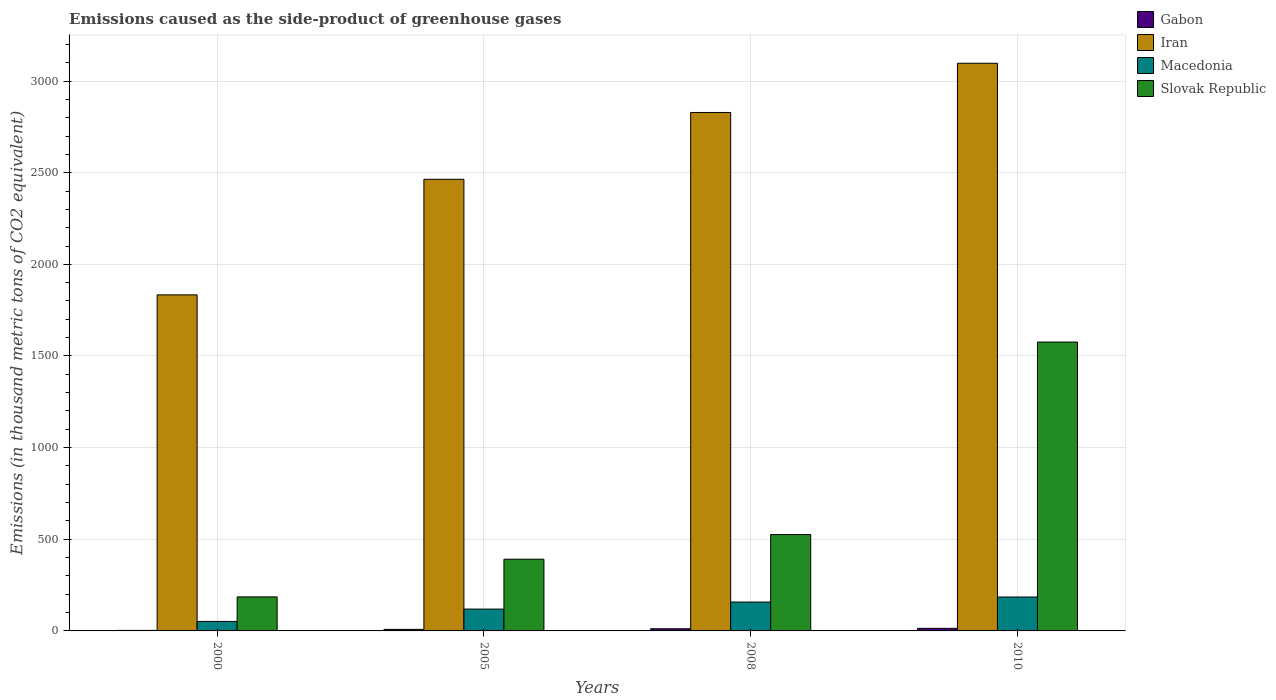What is the label of the 3rd group of bars from the left?
Your response must be concise. 2008. What is the emissions caused as the side-product of greenhouse gases in Iran in 2005?
Keep it short and to the point. 2464. Across all years, what is the maximum emissions caused as the side-product of greenhouse gases in Macedonia?
Your response must be concise. 185. Across all years, what is the minimum emissions caused as the side-product of greenhouse gases in Slovak Republic?
Your response must be concise. 185.6. In which year was the emissions caused as the side-product of greenhouse gases in Macedonia maximum?
Ensure brevity in your answer.  2010. What is the total emissions caused as the side-product of greenhouse gases in Macedonia in the graph?
Your answer should be very brief. 513.5. What is the difference between the emissions caused as the side-product of greenhouse gases in Slovak Republic in 2000 and that in 2005?
Keep it short and to the point. -205.7. What is the difference between the emissions caused as the side-product of greenhouse gases in Macedonia in 2000 and the emissions caused as the side-product of greenhouse gases in Iran in 2010?
Provide a succinct answer. -3045.2. What is the average emissions caused as the side-product of greenhouse gases in Slovak Republic per year?
Provide a succinct answer. 669.67. In the year 2010, what is the difference between the emissions caused as the side-product of greenhouse gases in Iran and emissions caused as the side-product of greenhouse gases in Slovak Republic?
Your answer should be very brief. 1521. In how many years, is the emissions caused as the side-product of greenhouse gases in Gabon greater than 2000 thousand metric tons?
Your response must be concise. 0. What is the ratio of the emissions caused as the side-product of greenhouse gases in Iran in 2000 to that in 2010?
Ensure brevity in your answer.  0.59. What is the difference between the highest and the second highest emissions caused as the side-product of greenhouse gases in Macedonia?
Give a very brief answer. 27.4. What is the difference between the highest and the lowest emissions caused as the side-product of greenhouse gases in Macedonia?
Provide a short and direct response. 133.2. Is the sum of the emissions caused as the side-product of greenhouse gases in Gabon in 2005 and 2008 greater than the maximum emissions caused as the side-product of greenhouse gases in Macedonia across all years?
Ensure brevity in your answer.  No. Is it the case that in every year, the sum of the emissions caused as the side-product of greenhouse gases in Gabon and emissions caused as the side-product of greenhouse gases in Slovak Republic is greater than the sum of emissions caused as the side-product of greenhouse gases in Iran and emissions caused as the side-product of greenhouse gases in Macedonia?
Give a very brief answer. No. What does the 1st bar from the left in 2000 represents?
Give a very brief answer. Gabon. What does the 2nd bar from the right in 2008 represents?
Make the answer very short. Macedonia. Is it the case that in every year, the sum of the emissions caused as the side-product of greenhouse gases in Gabon and emissions caused as the side-product of greenhouse gases in Iran is greater than the emissions caused as the side-product of greenhouse gases in Macedonia?
Offer a terse response. Yes. What is the difference between two consecutive major ticks on the Y-axis?
Give a very brief answer. 500. Are the values on the major ticks of Y-axis written in scientific E-notation?
Ensure brevity in your answer.  No. Does the graph contain grids?
Provide a short and direct response. Yes. Where does the legend appear in the graph?
Provide a short and direct response. Top right. How many legend labels are there?
Give a very brief answer. 4. How are the legend labels stacked?
Your answer should be compact. Vertical. What is the title of the graph?
Offer a very short reply. Emissions caused as the side-product of greenhouse gases. Does "Gambia, The" appear as one of the legend labels in the graph?
Your answer should be very brief. No. What is the label or title of the Y-axis?
Provide a succinct answer. Emissions (in thousand metric tons of CO2 equivalent). What is the Emissions (in thousand metric tons of CO2 equivalent) of Gabon in 2000?
Your answer should be very brief. 2.9. What is the Emissions (in thousand metric tons of CO2 equivalent) in Iran in 2000?
Make the answer very short. 1833.4. What is the Emissions (in thousand metric tons of CO2 equivalent) of Macedonia in 2000?
Provide a short and direct response. 51.8. What is the Emissions (in thousand metric tons of CO2 equivalent) of Slovak Republic in 2000?
Your answer should be compact. 185.6. What is the Emissions (in thousand metric tons of CO2 equivalent) of Gabon in 2005?
Offer a very short reply. 8.4. What is the Emissions (in thousand metric tons of CO2 equivalent) of Iran in 2005?
Offer a terse response. 2464. What is the Emissions (in thousand metric tons of CO2 equivalent) in Macedonia in 2005?
Provide a short and direct response. 119.1. What is the Emissions (in thousand metric tons of CO2 equivalent) of Slovak Republic in 2005?
Offer a terse response. 391.3. What is the Emissions (in thousand metric tons of CO2 equivalent) of Iran in 2008?
Provide a short and direct response. 2828.5. What is the Emissions (in thousand metric tons of CO2 equivalent) in Macedonia in 2008?
Your answer should be very brief. 157.6. What is the Emissions (in thousand metric tons of CO2 equivalent) of Slovak Republic in 2008?
Your answer should be compact. 525.8. What is the Emissions (in thousand metric tons of CO2 equivalent) in Iran in 2010?
Provide a succinct answer. 3097. What is the Emissions (in thousand metric tons of CO2 equivalent) in Macedonia in 2010?
Your response must be concise. 185. What is the Emissions (in thousand metric tons of CO2 equivalent) of Slovak Republic in 2010?
Offer a terse response. 1576. Across all years, what is the maximum Emissions (in thousand metric tons of CO2 equivalent) in Iran?
Your answer should be very brief. 3097. Across all years, what is the maximum Emissions (in thousand metric tons of CO2 equivalent) in Macedonia?
Your answer should be very brief. 185. Across all years, what is the maximum Emissions (in thousand metric tons of CO2 equivalent) of Slovak Republic?
Your answer should be compact. 1576. Across all years, what is the minimum Emissions (in thousand metric tons of CO2 equivalent) of Gabon?
Your answer should be very brief. 2.9. Across all years, what is the minimum Emissions (in thousand metric tons of CO2 equivalent) of Iran?
Your answer should be very brief. 1833.4. Across all years, what is the minimum Emissions (in thousand metric tons of CO2 equivalent) in Macedonia?
Offer a terse response. 51.8. Across all years, what is the minimum Emissions (in thousand metric tons of CO2 equivalent) of Slovak Republic?
Your answer should be very brief. 185.6. What is the total Emissions (in thousand metric tons of CO2 equivalent) of Gabon in the graph?
Your response must be concise. 37.1. What is the total Emissions (in thousand metric tons of CO2 equivalent) in Iran in the graph?
Offer a very short reply. 1.02e+04. What is the total Emissions (in thousand metric tons of CO2 equivalent) of Macedonia in the graph?
Your answer should be very brief. 513.5. What is the total Emissions (in thousand metric tons of CO2 equivalent) in Slovak Republic in the graph?
Offer a very short reply. 2678.7. What is the difference between the Emissions (in thousand metric tons of CO2 equivalent) in Gabon in 2000 and that in 2005?
Offer a terse response. -5.5. What is the difference between the Emissions (in thousand metric tons of CO2 equivalent) in Iran in 2000 and that in 2005?
Make the answer very short. -630.6. What is the difference between the Emissions (in thousand metric tons of CO2 equivalent) in Macedonia in 2000 and that in 2005?
Offer a terse response. -67.3. What is the difference between the Emissions (in thousand metric tons of CO2 equivalent) in Slovak Republic in 2000 and that in 2005?
Your response must be concise. -205.7. What is the difference between the Emissions (in thousand metric tons of CO2 equivalent) of Iran in 2000 and that in 2008?
Provide a short and direct response. -995.1. What is the difference between the Emissions (in thousand metric tons of CO2 equivalent) of Macedonia in 2000 and that in 2008?
Provide a succinct answer. -105.8. What is the difference between the Emissions (in thousand metric tons of CO2 equivalent) in Slovak Republic in 2000 and that in 2008?
Offer a very short reply. -340.2. What is the difference between the Emissions (in thousand metric tons of CO2 equivalent) of Iran in 2000 and that in 2010?
Provide a short and direct response. -1263.6. What is the difference between the Emissions (in thousand metric tons of CO2 equivalent) of Macedonia in 2000 and that in 2010?
Offer a very short reply. -133.2. What is the difference between the Emissions (in thousand metric tons of CO2 equivalent) in Slovak Republic in 2000 and that in 2010?
Your answer should be compact. -1390.4. What is the difference between the Emissions (in thousand metric tons of CO2 equivalent) in Gabon in 2005 and that in 2008?
Make the answer very short. -3.4. What is the difference between the Emissions (in thousand metric tons of CO2 equivalent) in Iran in 2005 and that in 2008?
Provide a succinct answer. -364.5. What is the difference between the Emissions (in thousand metric tons of CO2 equivalent) in Macedonia in 2005 and that in 2008?
Ensure brevity in your answer.  -38.5. What is the difference between the Emissions (in thousand metric tons of CO2 equivalent) of Slovak Republic in 2005 and that in 2008?
Your answer should be very brief. -134.5. What is the difference between the Emissions (in thousand metric tons of CO2 equivalent) in Iran in 2005 and that in 2010?
Offer a very short reply. -633. What is the difference between the Emissions (in thousand metric tons of CO2 equivalent) of Macedonia in 2005 and that in 2010?
Provide a short and direct response. -65.9. What is the difference between the Emissions (in thousand metric tons of CO2 equivalent) in Slovak Republic in 2005 and that in 2010?
Give a very brief answer. -1184.7. What is the difference between the Emissions (in thousand metric tons of CO2 equivalent) in Iran in 2008 and that in 2010?
Provide a succinct answer. -268.5. What is the difference between the Emissions (in thousand metric tons of CO2 equivalent) in Macedonia in 2008 and that in 2010?
Your answer should be compact. -27.4. What is the difference between the Emissions (in thousand metric tons of CO2 equivalent) of Slovak Republic in 2008 and that in 2010?
Keep it short and to the point. -1050.2. What is the difference between the Emissions (in thousand metric tons of CO2 equivalent) in Gabon in 2000 and the Emissions (in thousand metric tons of CO2 equivalent) in Iran in 2005?
Keep it short and to the point. -2461.1. What is the difference between the Emissions (in thousand metric tons of CO2 equivalent) of Gabon in 2000 and the Emissions (in thousand metric tons of CO2 equivalent) of Macedonia in 2005?
Ensure brevity in your answer.  -116.2. What is the difference between the Emissions (in thousand metric tons of CO2 equivalent) of Gabon in 2000 and the Emissions (in thousand metric tons of CO2 equivalent) of Slovak Republic in 2005?
Ensure brevity in your answer.  -388.4. What is the difference between the Emissions (in thousand metric tons of CO2 equivalent) in Iran in 2000 and the Emissions (in thousand metric tons of CO2 equivalent) in Macedonia in 2005?
Keep it short and to the point. 1714.3. What is the difference between the Emissions (in thousand metric tons of CO2 equivalent) in Iran in 2000 and the Emissions (in thousand metric tons of CO2 equivalent) in Slovak Republic in 2005?
Your answer should be compact. 1442.1. What is the difference between the Emissions (in thousand metric tons of CO2 equivalent) in Macedonia in 2000 and the Emissions (in thousand metric tons of CO2 equivalent) in Slovak Republic in 2005?
Ensure brevity in your answer.  -339.5. What is the difference between the Emissions (in thousand metric tons of CO2 equivalent) in Gabon in 2000 and the Emissions (in thousand metric tons of CO2 equivalent) in Iran in 2008?
Offer a terse response. -2825.6. What is the difference between the Emissions (in thousand metric tons of CO2 equivalent) in Gabon in 2000 and the Emissions (in thousand metric tons of CO2 equivalent) in Macedonia in 2008?
Provide a short and direct response. -154.7. What is the difference between the Emissions (in thousand metric tons of CO2 equivalent) of Gabon in 2000 and the Emissions (in thousand metric tons of CO2 equivalent) of Slovak Republic in 2008?
Keep it short and to the point. -522.9. What is the difference between the Emissions (in thousand metric tons of CO2 equivalent) in Iran in 2000 and the Emissions (in thousand metric tons of CO2 equivalent) in Macedonia in 2008?
Offer a very short reply. 1675.8. What is the difference between the Emissions (in thousand metric tons of CO2 equivalent) in Iran in 2000 and the Emissions (in thousand metric tons of CO2 equivalent) in Slovak Republic in 2008?
Make the answer very short. 1307.6. What is the difference between the Emissions (in thousand metric tons of CO2 equivalent) in Macedonia in 2000 and the Emissions (in thousand metric tons of CO2 equivalent) in Slovak Republic in 2008?
Offer a terse response. -474. What is the difference between the Emissions (in thousand metric tons of CO2 equivalent) in Gabon in 2000 and the Emissions (in thousand metric tons of CO2 equivalent) in Iran in 2010?
Your response must be concise. -3094.1. What is the difference between the Emissions (in thousand metric tons of CO2 equivalent) of Gabon in 2000 and the Emissions (in thousand metric tons of CO2 equivalent) of Macedonia in 2010?
Your answer should be very brief. -182.1. What is the difference between the Emissions (in thousand metric tons of CO2 equivalent) of Gabon in 2000 and the Emissions (in thousand metric tons of CO2 equivalent) of Slovak Republic in 2010?
Offer a very short reply. -1573.1. What is the difference between the Emissions (in thousand metric tons of CO2 equivalent) in Iran in 2000 and the Emissions (in thousand metric tons of CO2 equivalent) in Macedonia in 2010?
Keep it short and to the point. 1648.4. What is the difference between the Emissions (in thousand metric tons of CO2 equivalent) in Iran in 2000 and the Emissions (in thousand metric tons of CO2 equivalent) in Slovak Republic in 2010?
Your answer should be compact. 257.4. What is the difference between the Emissions (in thousand metric tons of CO2 equivalent) of Macedonia in 2000 and the Emissions (in thousand metric tons of CO2 equivalent) of Slovak Republic in 2010?
Your answer should be very brief. -1524.2. What is the difference between the Emissions (in thousand metric tons of CO2 equivalent) of Gabon in 2005 and the Emissions (in thousand metric tons of CO2 equivalent) of Iran in 2008?
Provide a succinct answer. -2820.1. What is the difference between the Emissions (in thousand metric tons of CO2 equivalent) of Gabon in 2005 and the Emissions (in thousand metric tons of CO2 equivalent) of Macedonia in 2008?
Make the answer very short. -149.2. What is the difference between the Emissions (in thousand metric tons of CO2 equivalent) of Gabon in 2005 and the Emissions (in thousand metric tons of CO2 equivalent) of Slovak Republic in 2008?
Your answer should be very brief. -517.4. What is the difference between the Emissions (in thousand metric tons of CO2 equivalent) in Iran in 2005 and the Emissions (in thousand metric tons of CO2 equivalent) in Macedonia in 2008?
Offer a terse response. 2306.4. What is the difference between the Emissions (in thousand metric tons of CO2 equivalent) of Iran in 2005 and the Emissions (in thousand metric tons of CO2 equivalent) of Slovak Republic in 2008?
Offer a very short reply. 1938.2. What is the difference between the Emissions (in thousand metric tons of CO2 equivalent) in Macedonia in 2005 and the Emissions (in thousand metric tons of CO2 equivalent) in Slovak Republic in 2008?
Your answer should be very brief. -406.7. What is the difference between the Emissions (in thousand metric tons of CO2 equivalent) in Gabon in 2005 and the Emissions (in thousand metric tons of CO2 equivalent) in Iran in 2010?
Make the answer very short. -3088.6. What is the difference between the Emissions (in thousand metric tons of CO2 equivalent) of Gabon in 2005 and the Emissions (in thousand metric tons of CO2 equivalent) of Macedonia in 2010?
Your answer should be compact. -176.6. What is the difference between the Emissions (in thousand metric tons of CO2 equivalent) in Gabon in 2005 and the Emissions (in thousand metric tons of CO2 equivalent) in Slovak Republic in 2010?
Give a very brief answer. -1567.6. What is the difference between the Emissions (in thousand metric tons of CO2 equivalent) of Iran in 2005 and the Emissions (in thousand metric tons of CO2 equivalent) of Macedonia in 2010?
Give a very brief answer. 2279. What is the difference between the Emissions (in thousand metric tons of CO2 equivalent) in Iran in 2005 and the Emissions (in thousand metric tons of CO2 equivalent) in Slovak Republic in 2010?
Your answer should be compact. 888. What is the difference between the Emissions (in thousand metric tons of CO2 equivalent) of Macedonia in 2005 and the Emissions (in thousand metric tons of CO2 equivalent) of Slovak Republic in 2010?
Your answer should be very brief. -1456.9. What is the difference between the Emissions (in thousand metric tons of CO2 equivalent) of Gabon in 2008 and the Emissions (in thousand metric tons of CO2 equivalent) of Iran in 2010?
Your answer should be compact. -3085.2. What is the difference between the Emissions (in thousand metric tons of CO2 equivalent) in Gabon in 2008 and the Emissions (in thousand metric tons of CO2 equivalent) in Macedonia in 2010?
Ensure brevity in your answer.  -173.2. What is the difference between the Emissions (in thousand metric tons of CO2 equivalent) of Gabon in 2008 and the Emissions (in thousand metric tons of CO2 equivalent) of Slovak Republic in 2010?
Your answer should be very brief. -1564.2. What is the difference between the Emissions (in thousand metric tons of CO2 equivalent) of Iran in 2008 and the Emissions (in thousand metric tons of CO2 equivalent) of Macedonia in 2010?
Make the answer very short. 2643.5. What is the difference between the Emissions (in thousand metric tons of CO2 equivalent) of Iran in 2008 and the Emissions (in thousand metric tons of CO2 equivalent) of Slovak Republic in 2010?
Provide a short and direct response. 1252.5. What is the difference between the Emissions (in thousand metric tons of CO2 equivalent) in Macedonia in 2008 and the Emissions (in thousand metric tons of CO2 equivalent) in Slovak Republic in 2010?
Keep it short and to the point. -1418.4. What is the average Emissions (in thousand metric tons of CO2 equivalent) of Gabon per year?
Your answer should be compact. 9.28. What is the average Emissions (in thousand metric tons of CO2 equivalent) in Iran per year?
Offer a terse response. 2555.72. What is the average Emissions (in thousand metric tons of CO2 equivalent) of Macedonia per year?
Your answer should be compact. 128.38. What is the average Emissions (in thousand metric tons of CO2 equivalent) of Slovak Republic per year?
Your answer should be very brief. 669.67. In the year 2000, what is the difference between the Emissions (in thousand metric tons of CO2 equivalent) in Gabon and Emissions (in thousand metric tons of CO2 equivalent) in Iran?
Offer a very short reply. -1830.5. In the year 2000, what is the difference between the Emissions (in thousand metric tons of CO2 equivalent) of Gabon and Emissions (in thousand metric tons of CO2 equivalent) of Macedonia?
Your answer should be compact. -48.9. In the year 2000, what is the difference between the Emissions (in thousand metric tons of CO2 equivalent) in Gabon and Emissions (in thousand metric tons of CO2 equivalent) in Slovak Republic?
Provide a short and direct response. -182.7. In the year 2000, what is the difference between the Emissions (in thousand metric tons of CO2 equivalent) of Iran and Emissions (in thousand metric tons of CO2 equivalent) of Macedonia?
Provide a short and direct response. 1781.6. In the year 2000, what is the difference between the Emissions (in thousand metric tons of CO2 equivalent) in Iran and Emissions (in thousand metric tons of CO2 equivalent) in Slovak Republic?
Ensure brevity in your answer.  1647.8. In the year 2000, what is the difference between the Emissions (in thousand metric tons of CO2 equivalent) of Macedonia and Emissions (in thousand metric tons of CO2 equivalent) of Slovak Republic?
Provide a short and direct response. -133.8. In the year 2005, what is the difference between the Emissions (in thousand metric tons of CO2 equivalent) of Gabon and Emissions (in thousand metric tons of CO2 equivalent) of Iran?
Your response must be concise. -2455.6. In the year 2005, what is the difference between the Emissions (in thousand metric tons of CO2 equivalent) in Gabon and Emissions (in thousand metric tons of CO2 equivalent) in Macedonia?
Keep it short and to the point. -110.7. In the year 2005, what is the difference between the Emissions (in thousand metric tons of CO2 equivalent) in Gabon and Emissions (in thousand metric tons of CO2 equivalent) in Slovak Republic?
Your answer should be very brief. -382.9. In the year 2005, what is the difference between the Emissions (in thousand metric tons of CO2 equivalent) in Iran and Emissions (in thousand metric tons of CO2 equivalent) in Macedonia?
Offer a terse response. 2344.9. In the year 2005, what is the difference between the Emissions (in thousand metric tons of CO2 equivalent) of Iran and Emissions (in thousand metric tons of CO2 equivalent) of Slovak Republic?
Keep it short and to the point. 2072.7. In the year 2005, what is the difference between the Emissions (in thousand metric tons of CO2 equivalent) in Macedonia and Emissions (in thousand metric tons of CO2 equivalent) in Slovak Republic?
Offer a terse response. -272.2. In the year 2008, what is the difference between the Emissions (in thousand metric tons of CO2 equivalent) of Gabon and Emissions (in thousand metric tons of CO2 equivalent) of Iran?
Provide a succinct answer. -2816.7. In the year 2008, what is the difference between the Emissions (in thousand metric tons of CO2 equivalent) in Gabon and Emissions (in thousand metric tons of CO2 equivalent) in Macedonia?
Ensure brevity in your answer.  -145.8. In the year 2008, what is the difference between the Emissions (in thousand metric tons of CO2 equivalent) in Gabon and Emissions (in thousand metric tons of CO2 equivalent) in Slovak Republic?
Give a very brief answer. -514. In the year 2008, what is the difference between the Emissions (in thousand metric tons of CO2 equivalent) of Iran and Emissions (in thousand metric tons of CO2 equivalent) of Macedonia?
Ensure brevity in your answer.  2670.9. In the year 2008, what is the difference between the Emissions (in thousand metric tons of CO2 equivalent) of Iran and Emissions (in thousand metric tons of CO2 equivalent) of Slovak Republic?
Provide a succinct answer. 2302.7. In the year 2008, what is the difference between the Emissions (in thousand metric tons of CO2 equivalent) in Macedonia and Emissions (in thousand metric tons of CO2 equivalent) in Slovak Republic?
Offer a very short reply. -368.2. In the year 2010, what is the difference between the Emissions (in thousand metric tons of CO2 equivalent) in Gabon and Emissions (in thousand metric tons of CO2 equivalent) in Iran?
Make the answer very short. -3083. In the year 2010, what is the difference between the Emissions (in thousand metric tons of CO2 equivalent) in Gabon and Emissions (in thousand metric tons of CO2 equivalent) in Macedonia?
Offer a terse response. -171. In the year 2010, what is the difference between the Emissions (in thousand metric tons of CO2 equivalent) of Gabon and Emissions (in thousand metric tons of CO2 equivalent) of Slovak Republic?
Ensure brevity in your answer.  -1562. In the year 2010, what is the difference between the Emissions (in thousand metric tons of CO2 equivalent) in Iran and Emissions (in thousand metric tons of CO2 equivalent) in Macedonia?
Your answer should be very brief. 2912. In the year 2010, what is the difference between the Emissions (in thousand metric tons of CO2 equivalent) in Iran and Emissions (in thousand metric tons of CO2 equivalent) in Slovak Republic?
Ensure brevity in your answer.  1521. In the year 2010, what is the difference between the Emissions (in thousand metric tons of CO2 equivalent) in Macedonia and Emissions (in thousand metric tons of CO2 equivalent) in Slovak Republic?
Your response must be concise. -1391. What is the ratio of the Emissions (in thousand metric tons of CO2 equivalent) in Gabon in 2000 to that in 2005?
Make the answer very short. 0.35. What is the ratio of the Emissions (in thousand metric tons of CO2 equivalent) in Iran in 2000 to that in 2005?
Give a very brief answer. 0.74. What is the ratio of the Emissions (in thousand metric tons of CO2 equivalent) in Macedonia in 2000 to that in 2005?
Give a very brief answer. 0.43. What is the ratio of the Emissions (in thousand metric tons of CO2 equivalent) of Slovak Republic in 2000 to that in 2005?
Provide a succinct answer. 0.47. What is the ratio of the Emissions (in thousand metric tons of CO2 equivalent) of Gabon in 2000 to that in 2008?
Your response must be concise. 0.25. What is the ratio of the Emissions (in thousand metric tons of CO2 equivalent) in Iran in 2000 to that in 2008?
Ensure brevity in your answer.  0.65. What is the ratio of the Emissions (in thousand metric tons of CO2 equivalent) in Macedonia in 2000 to that in 2008?
Keep it short and to the point. 0.33. What is the ratio of the Emissions (in thousand metric tons of CO2 equivalent) of Slovak Republic in 2000 to that in 2008?
Your answer should be very brief. 0.35. What is the ratio of the Emissions (in thousand metric tons of CO2 equivalent) in Gabon in 2000 to that in 2010?
Your answer should be compact. 0.21. What is the ratio of the Emissions (in thousand metric tons of CO2 equivalent) in Iran in 2000 to that in 2010?
Offer a very short reply. 0.59. What is the ratio of the Emissions (in thousand metric tons of CO2 equivalent) of Macedonia in 2000 to that in 2010?
Your answer should be compact. 0.28. What is the ratio of the Emissions (in thousand metric tons of CO2 equivalent) of Slovak Republic in 2000 to that in 2010?
Offer a very short reply. 0.12. What is the ratio of the Emissions (in thousand metric tons of CO2 equivalent) of Gabon in 2005 to that in 2008?
Provide a succinct answer. 0.71. What is the ratio of the Emissions (in thousand metric tons of CO2 equivalent) of Iran in 2005 to that in 2008?
Make the answer very short. 0.87. What is the ratio of the Emissions (in thousand metric tons of CO2 equivalent) of Macedonia in 2005 to that in 2008?
Provide a short and direct response. 0.76. What is the ratio of the Emissions (in thousand metric tons of CO2 equivalent) of Slovak Republic in 2005 to that in 2008?
Ensure brevity in your answer.  0.74. What is the ratio of the Emissions (in thousand metric tons of CO2 equivalent) in Iran in 2005 to that in 2010?
Ensure brevity in your answer.  0.8. What is the ratio of the Emissions (in thousand metric tons of CO2 equivalent) of Macedonia in 2005 to that in 2010?
Keep it short and to the point. 0.64. What is the ratio of the Emissions (in thousand metric tons of CO2 equivalent) of Slovak Republic in 2005 to that in 2010?
Your answer should be compact. 0.25. What is the ratio of the Emissions (in thousand metric tons of CO2 equivalent) of Gabon in 2008 to that in 2010?
Your response must be concise. 0.84. What is the ratio of the Emissions (in thousand metric tons of CO2 equivalent) of Iran in 2008 to that in 2010?
Give a very brief answer. 0.91. What is the ratio of the Emissions (in thousand metric tons of CO2 equivalent) of Macedonia in 2008 to that in 2010?
Keep it short and to the point. 0.85. What is the ratio of the Emissions (in thousand metric tons of CO2 equivalent) of Slovak Republic in 2008 to that in 2010?
Your answer should be compact. 0.33. What is the difference between the highest and the second highest Emissions (in thousand metric tons of CO2 equivalent) of Iran?
Provide a short and direct response. 268.5. What is the difference between the highest and the second highest Emissions (in thousand metric tons of CO2 equivalent) in Macedonia?
Your answer should be very brief. 27.4. What is the difference between the highest and the second highest Emissions (in thousand metric tons of CO2 equivalent) of Slovak Republic?
Offer a terse response. 1050.2. What is the difference between the highest and the lowest Emissions (in thousand metric tons of CO2 equivalent) of Iran?
Make the answer very short. 1263.6. What is the difference between the highest and the lowest Emissions (in thousand metric tons of CO2 equivalent) of Macedonia?
Ensure brevity in your answer.  133.2. What is the difference between the highest and the lowest Emissions (in thousand metric tons of CO2 equivalent) in Slovak Republic?
Your answer should be compact. 1390.4. 